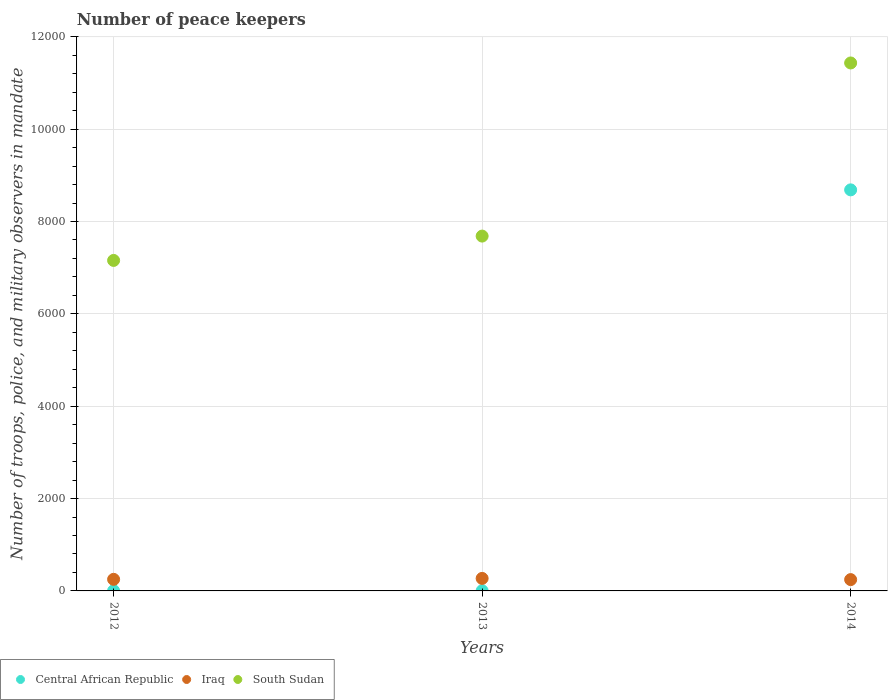Is the number of dotlines equal to the number of legend labels?
Give a very brief answer. Yes. What is the number of peace keepers in in Central African Republic in 2013?
Offer a very short reply. 4. Across all years, what is the maximum number of peace keepers in in Central African Republic?
Make the answer very short. 8685. Across all years, what is the minimum number of peace keepers in in South Sudan?
Your answer should be very brief. 7157. In which year was the number of peace keepers in in South Sudan maximum?
Provide a short and direct response. 2014. In which year was the number of peace keepers in in Iraq minimum?
Give a very brief answer. 2014. What is the total number of peace keepers in in South Sudan in the graph?
Keep it short and to the point. 2.63e+04. What is the difference between the number of peace keepers in in Central African Republic in 2012 and that in 2014?
Keep it short and to the point. -8681. What is the difference between the number of peace keepers in in Iraq in 2013 and the number of peace keepers in in Central African Republic in 2014?
Ensure brevity in your answer.  -8414. What is the average number of peace keepers in in Iraq per year?
Make the answer very short. 255.67. In the year 2013, what is the difference between the number of peace keepers in in Iraq and number of peace keepers in in Central African Republic?
Make the answer very short. 267. In how many years, is the number of peace keepers in in Iraq greater than 9200?
Provide a short and direct response. 0. What is the ratio of the number of peace keepers in in Iraq in 2012 to that in 2014?
Offer a terse response. 1.02. What is the difference between the highest and the second highest number of peace keepers in in South Sudan?
Provide a succinct answer. 3749. What is the difference between the highest and the lowest number of peace keepers in in Iraq?
Your response must be concise. 26. Is the sum of the number of peace keepers in in Iraq in 2012 and 2014 greater than the maximum number of peace keepers in in Central African Republic across all years?
Give a very brief answer. No. Is it the case that in every year, the sum of the number of peace keepers in in South Sudan and number of peace keepers in in Central African Republic  is greater than the number of peace keepers in in Iraq?
Offer a terse response. Yes. How many dotlines are there?
Make the answer very short. 3. How many years are there in the graph?
Your answer should be compact. 3. What is the difference between two consecutive major ticks on the Y-axis?
Offer a terse response. 2000. Are the values on the major ticks of Y-axis written in scientific E-notation?
Offer a very short reply. No. Does the graph contain any zero values?
Provide a succinct answer. No. How many legend labels are there?
Keep it short and to the point. 3. How are the legend labels stacked?
Your answer should be compact. Horizontal. What is the title of the graph?
Your answer should be very brief. Number of peace keepers. What is the label or title of the X-axis?
Your answer should be very brief. Years. What is the label or title of the Y-axis?
Give a very brief answer. Number of troops, police, and military observers in mandate. What is the Number of troops, police, and military observers in mandate in Central African Republic in 2012?
Your response must be concise. 4. What is the Number of troops, police, and military observers in mandate in Iraq in 2012?
Provide a succinct answer. 251. What is the Number of troops, police, and military observers in mandate of South Sudan in 2012?
Make the answer very short. 7157. What is the Number of troops, police, and military observers in mandate in Central African Republic in 2013?
Provide a succinct answer. 4. What is the Number of troops, police, and military observers in mandate of Iraq in 2013?
Give a very brief answer. 271. What is the Number of troops, police, and military observers in mandate in South Sudan in 2013?
Offer a very short reply. 7684. What is the Number of troops, police, and military observers in mandate of Central African Republic in 2014?
Your response must be concise. 8685. What is the Number of troops, police, and military observers in mandate of Iraq in 2014?
Offer a very short reply. 245. What is the Number of troops, police, and military observers in mandate in South Sudan in 2014?
Provide a succinct answer. 1.14e+04. Across all years, what is the maximum Number of troops, police, and military observers in mandate of Central African Republic?
Ensure brevity in your answer.  8685. Across all years, what is the maximum Number of troops, police, and military observers in mandate in Iraq?
Give a very brief answer. 271. Across all years, what is the maximum Number of troops, police, and military observers in mandate in South Sudan?
Ensure brevity in your answer.  1.14e+04. Across all years, what is the minimum Number of troops, police, and military observers in mandate of Iraq?
Provide a short and direct response. 245. Across all years, what is the minimum Number of troops, police, and military observers in mandate in South Sudan?
Ensure brevity in your answer.  7157. What is the total Number of troops, police, and military observers in mandate in Central African Republic in the graph?
Your answer should be compact. 8693. What is the total Number of troops, police, and military observers in mandate of Iraq in the graph?
Offer a very short reply. 767. What is the total Number of troops, police, and military observers in mandate in South Sudan in the graph?
Offer a very short reply. 2.63e+04. What is the difference between the Number of troops, police, and military observers in mandate of South Sudan in 2012 and that in 2013?
Provide a succinct answer. -527. What is the difference between the Number of troops, police, and military observers in mandate of Central African Republic in 2012 and that in 2014?
Offer a terse response. -8681. What is the difference between the Number of troops, police, and military observers in mandate of Iraq in 2012 and that in 2014?
Provide a short and direct response. 6. What is the difference between the Number of troops, police, and military observers in mandate in South Sudan in 2012 and that in 2014?
Your response must be concise. -4276. What is the difference between the Number of troops, police, and military observers in mandate of Central African Republic in 2013 and that in 2014?
Ensure brevity in your answer.  -8681. What is the difference between the Number of troops, police, and military observers in mandate in South Sudan in 2013 and that in 2014?
Offer a terse response. -3749. What is the difference between the Number of troops, police, and military observers in mandate of Central African Republic in 2012 and the Number of troops, police, and military observers in mandate of Iraq in 2013?
Your answer should be compact. -267. What is the difference between the Number of troops, police, and military observers in mandate in Central African Republic in 2012 and the Number of troops, police, and military observers in mandate in South Sudan in 2013?
Your answer should be compact. -7680. What is the difference between the Number of troops, police, and military observers in mandate of Iraq in 2012 and the Number of troops, police, and military observers in mandate of South Sudan in 2013?
Keep it short and to the point. -7433. What is the difference between the Number of troops, police, and military observers in mandate in Central African Republic in 2012 and the Number of troops, police, and military observers in mandate in Iraq in 2014?
Give a very brief answer. -241. What is the difference between the Number of troops, police, and military observers in mandate in Central African Republic in 2012 and the Number of troops, police, and military observers in mandate in South Sudan in 2014?
Your response must be concise. -1.14e+04. What is the difference between the Number of troops, police, and military observers in mandate of Iraq in 2012 and the Number of troops, police, and military observers in mandate of South Sudan in 2014?
Ensure brevity in your answer.  -1.12e+04. What is the difference between the Number of troops, police, and military observers in mandate in Central African Republic in 2013 and the Number of troops, police, and military observers in mandate in Iraq in 2014?
Keep it short and to the point. -241. What is the difference between the Number of troops, police, and military observers in mandate in Central African Republic in 2013 and the Number of troops, police, and military observers in mandate in South Sudan in 2014?
Offer a very short reply. -1.14e+04. What is the difference between the Number of troops, police, and military observers in mandate in Iraq in 2013 and the Number of troops, police, and military observers in mandate in South Sudan in 2014?
Provide a succinct answer. -1.12e+04. What is the average Number of troops, police, and military observers in mandate in Central African Republic per year?
Offer a very short reply. 2897.67. What is the average Number of troops, police, and military observers in mandate of Iraq per year?
Your response must be concise. 255.67. What is the average Number of troops, police, and military observers in mandate of South Sudan per year?
Ensure brevity in your answer.  8758. In the year 2012, what is the difference between the Number of troops, police, and military observers in mandate of Central African Republic and Number of troops, police, and military observers in mandate of Iraq?
Your response must be concise. -247. In the year 2012, what is the difference between the Number of troops, police, and military observers in mandate of Central African Republic and Number of troops, police, and military observers in mandate of South Sudan?
Your answer should be very brief. -7153. In the year 2012, what is the difference between the Number of troops, police, and military observers in mandate in Iraq and Number of troops, police, and military observers in mandate in South Sudan?
Make the answer very short. -6906. In the year 2013, what is the difference between the Number of troops, police, and military observers in mandate in Central African Republic and Number of troops, police, and military observers in mandate in Iraq?
Offer a terse response. -267. In the year 2013, what is the difference between the Number of troops, police, and military observers in mandate in Central African Republic and Number of troops, police, and military observers in mandate in South Sudan?
Your answer should be compact. -7680. In the year 2013, what is the difference between the Number of troops, police, and military observers in mandate in Iraq and Number of troops, police, and military observers in mandate in South Sudan?
Keep it short and to the point. -7413. In the year 2014, what is the difference between the Number of troops, police, and military observers in mandate of Central African Republic and Number of troops, police, and military observers in mandate of Iraq?
Ensure brevity in your answer.  8440. In the year 2014, what is the difference between the Number of troops, police, and military observers in mandate of Central African Republic and Number of troops, police, and military observers in mandate of South Sudan?
Make the answer very short. -2748. In the year 2014, what is the difference between the Number of troops, police, and military observers in mandate in Iraq and Number of troops, police, and military observers in mandate in South Sudan?
Ensure brevity in your answer.  -1.12e+04. What is the ratio of the Number of troops, police, and military observers in mandate of Iraq in 2012 to that in 2013?
Provide a short and direct response. 0.93. What is the ratio of the Number of troops, police, and military observers in mandate in South Sudan in 2012 to that in 2013?
Make the answer very short. 0.93. What is the ratio of the Number of troops, police, and military observers in mandate in Central African Republic in 2012 to that in 2014?
Your answer should be compact. 0. What is the ratio of the Number of troops, police, and military observers in mandate in Iraq in 2012 to that in 2014?
Offer a very short reply. 1.02. What is the ratio of the Number of troops, police, and military observers in mandate of South Sudan in 2012 to that in 2014?
Offer a very short reply. 0.63. What is the ratio of the Number of troops, police, and military observers in mandate of Iraq in 2013 to that in 2014?
Your response must be concise. 1.11. What is the ratio of the Number of troops, police, and military observers in mandate of South Sudan in 2013 to that in 2014?
Your answer should be compact. 0.67. What is the difference between the highest and the second highest Number of troops, police, and military observers in mandate in Central African Republic?
Provide a succinct answer. 8681. What is the difference between the highest and the second highest Number of troops, police, and military observers in mandate of South Sudan?
Keep it short and to the point. 3749. What is the difference between the highest and the lowest Number of troops, police, and military observers in mandate of Central African Republic?
Your answer should be compact. 8681. What is the difference between the highest and the lowest Number of troops, police, and military observers in mandate in Iraq?
Offer a terse response. 26. What is the difference between the highest and the lowest Number of troops, police, and military observers in mandate in South Sudan?
Your answer should be compact. 4276. 